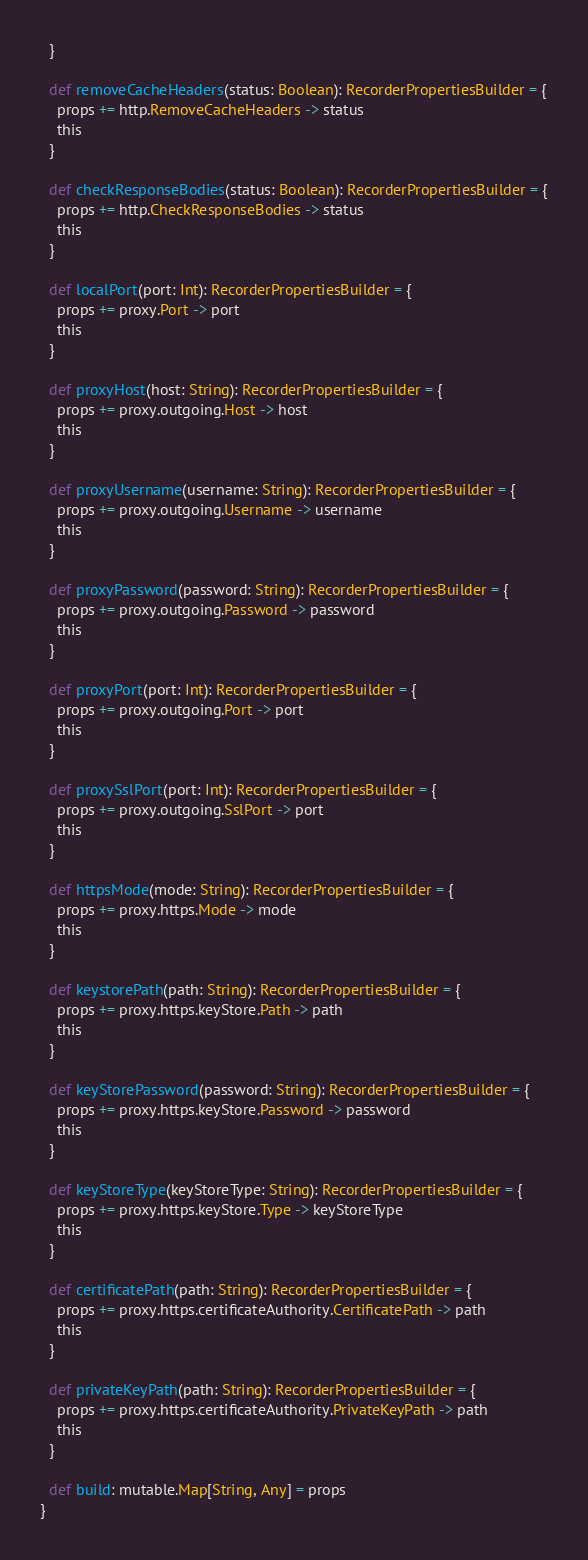<code> <loc_0><loc_0><loc_500><loc_500><_Scala_>  }

  def removeCacheHeaders(status: Boolean): RecorderPropertiesBuilder = {
    props += http.RemoveCacheHeaders -> status
    this
  }

  def checkResponseBodies(status: Boolean): RecorderPropertiesBuilder = {
    props += http.CheckResponseBodies -> status
    this
  }

  def localPort(port: Int): RecorderPropertiesBuilder = {
    props += proxy.Port -> port
    this
  }

  def proxyHost(host: String): RecorderPropertiesBuilder = {
    props += proxy.outgoing.Host -> host
    this
  }

  def proxyUsername(username: String): RecorderPropertiesBuilder = {
    props += proxy.outgoing.Username -> username
    this
  }

  def proxyPassword(password: String): RecorderPropertiesBuilder = {
    props += proxy.outgoing.Password -> password
    this
  }

  def proxyPort(port: Int): RecorderPropertiesBuilder = {
    props += proxy.outgoing.Port -> port
    this
  }

  def proxySslPort(port: Int): RecorderPropertiesBuilder = {
    props += proxy.outgoing.SslPort -> port
    this
  }

  def httpsMode(mode: String): RecorderPropertiesBuilder = {
    props += proxy.https.Mode -> mode
    this
  }

  def keystorePath(path: String): RecorderPropertiesBuilder = {
    props += proxy.https.keyStore.Path -> path
    this
  }

  def keyStorePassword(password: String): RecorderPropertiesBuilder = {
    props += proxy.https.keyStore.Password -> password
    this
  }

  def keyStoreType(keyStoreType: String): RecorderPropertiesBuilder = {
    props += proxy.https.keyStore.Type -> keyStoreType
    this
  }

  def certificatePath(path: String): RecorderPropertiesBuilder = {
    props += proxy.https.certificateAuthority.CertificatePath -> path
    this
  }

  def privateKeyPath(path: String): RecorderPropertiesBuilder = {
    props += proxy.https.certificateAuthority.PrivateKeyPath -> path
    this
  }

  def build: mutable.Map[String, Any] = props
}
</code> 